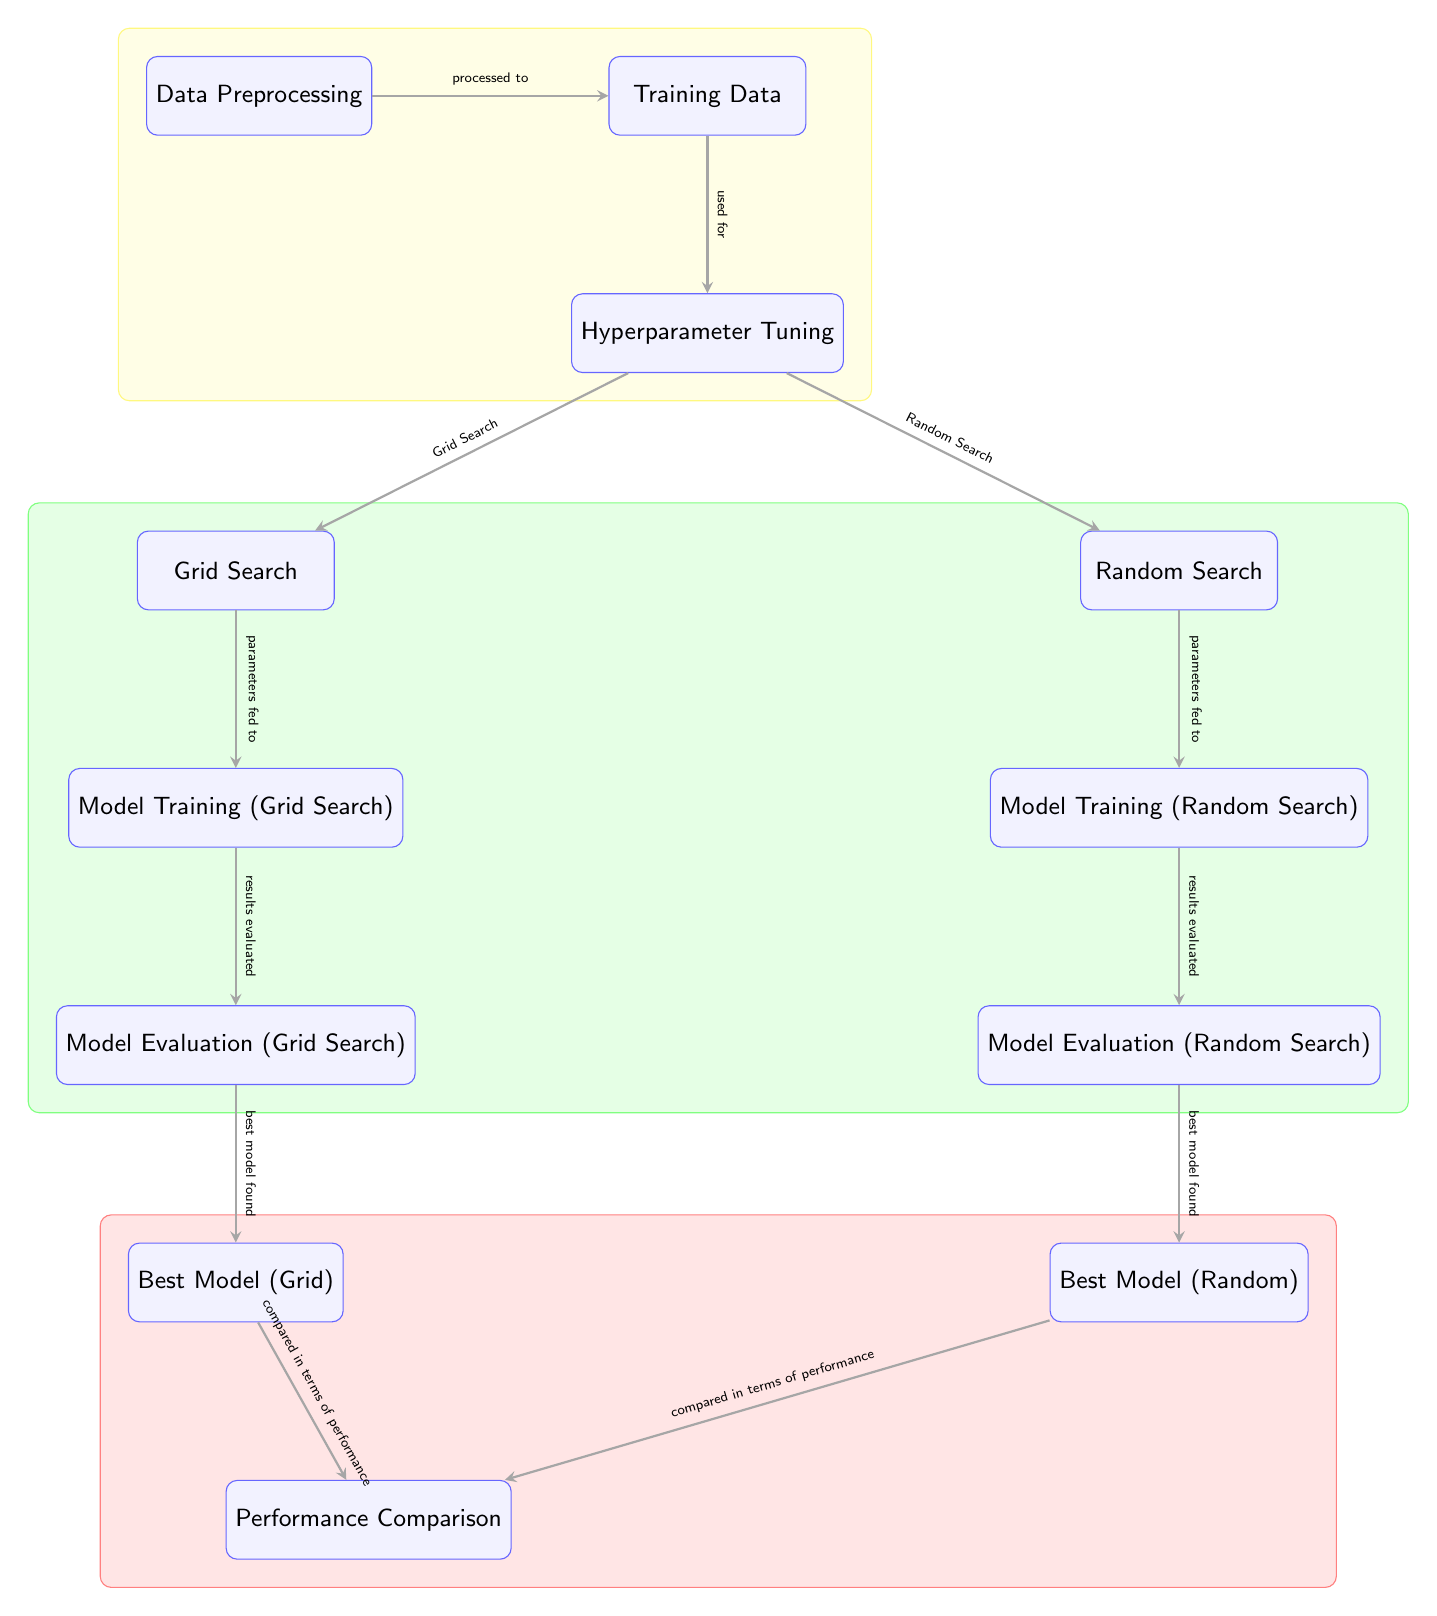What are the two search methods depicted for hyperparameter tuning? The diagram shows two search methods for hyperparameter tuning labeled as "Grid Search" and "Random Search," located below the "Hyperparameter Tuning" node.
Answer: Grid Search, Random Search How many models are evaluated in the tuning process? According to the diagram, two evaluations occur: one for the grid search results and one for the random search results, as represented by nodes "Model Evaluation (Grid Search)" and "Model Evaluation (Random Search)."
Answer: 2 Which step follows after hyperparameter tuning? The diagram indicates that after the tuning step, the next action is model training specific to the search methods, requiring processing of hyperparameters, as illustrated by "Model Training (Grid Search)" and "Model Training (Random Search)."
Answer: Model Training What is the relationship between the "Best Model (Grid)" and "Performance Comparison"? The diagram shows an arrow from "Best Model (Grid)" to "Performance Comparison," indicating that the best model derived from grid search is being compared in terms of performance against the random search model.
Answer: Compared in terms of performance What color represents the "Data Preprocessing" node and its connected nodes? The background of the "Data Preprocessing" node and its connected "Training Data" and "Hyperparameter Tuning" nodes is colored yellow, as indicated by the background styling applied to the box encompassing those nodes.
Answer: Yellow Which part of the diagram represents the actual search process for hyperparameters? The sections labeled "Grid Search" and "Random Search" within the tuning process illustrate the actual search techniques being employed, as they directly stem from the "Hyperparameter Tuning" node.
Answer: Grid Search, Random Search How many edges are drawn from the "Model Evaluation (Grid Search)" node? The diagram shows one outgoing edge from the "Model Evaluation (Grid Search)" node leading to the "Best Model (Grid)" node, illustrating the evaluation relationship.
Answer: 1 What is the color of the background for the model evaluation nodes? The nodes related to model evaluations for both grid search and random search are enclosed in a green background, as marked in the diagram layout.
Answer: Green 